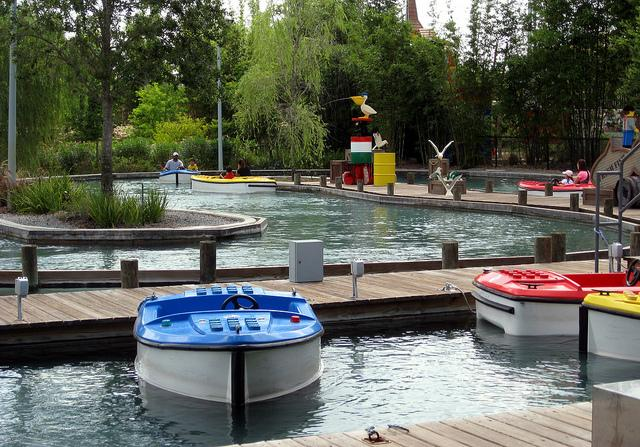What type of bird is on the red white and green barrel? Please explain your reasoning. pelican. The bird is a water bird. it is a pelican and likes fish. 